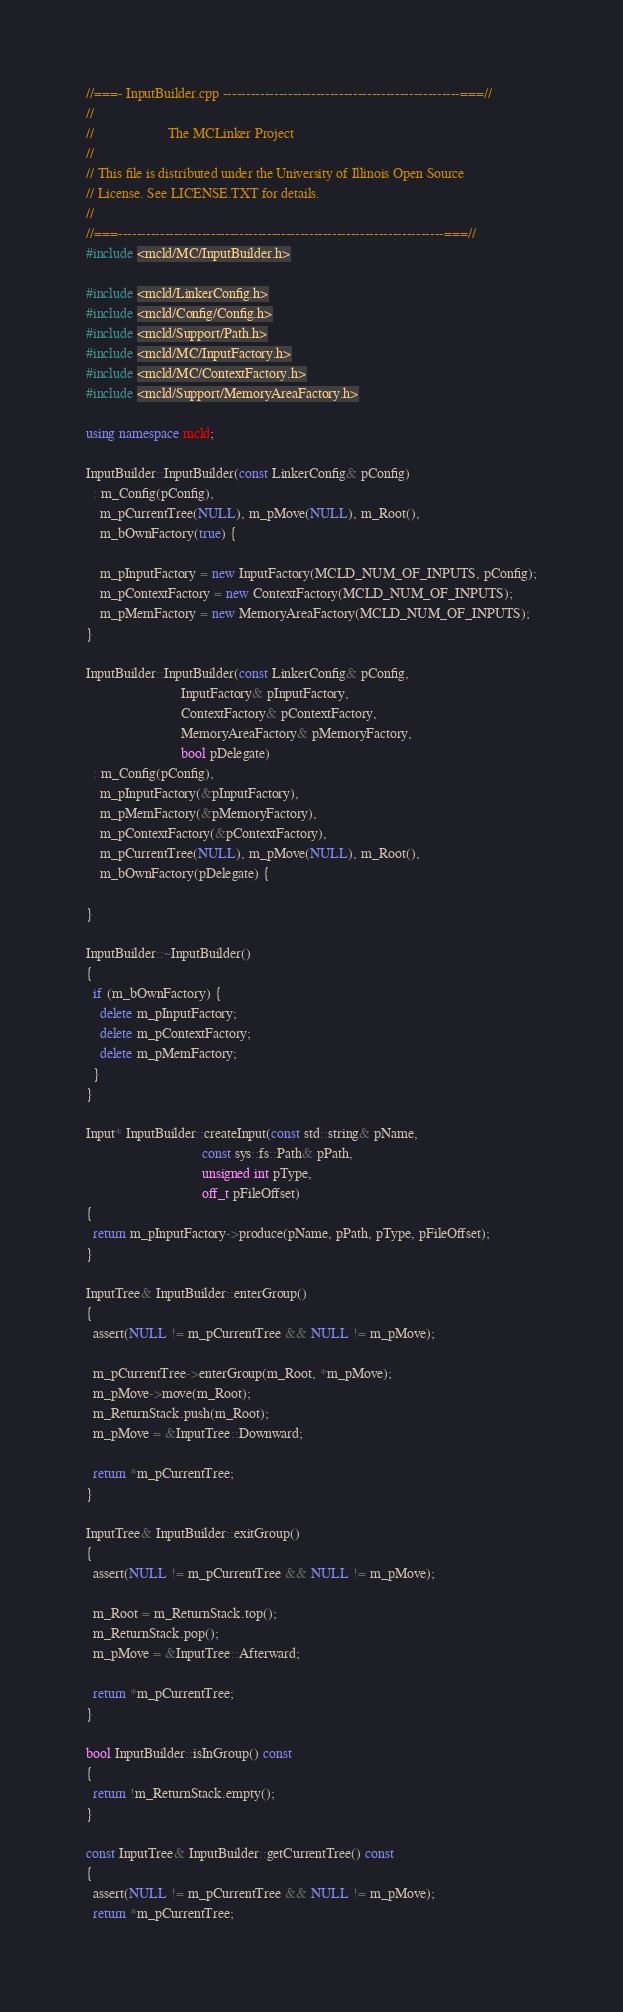<code> <loc_0><loc_0><loc_500><loc_500><_C++_>//===- InputBuilder.cpp ---------------------------------------------------===//
//
//                     The MCLinker Project
//
// This file is distributed under the University of Illinois Open Source
// License. See LICENSE.TXT for details.
//
//===----------------------------------------------------------------------===//
#include <mcld/MC/InputBuilder.h>

#include <mcld/LinkerConfig.h>
#include <mcld/Config/Config.h>
#include <mcld/Support/Path.h>
#include <mcld/MC/InputFactory.h>
#include <mcld/MC/ContextFactory.h>
#include <mcld/Support/MemoryAreaFactory.h>

using namespace mcld;

InputBuilder::InputBuilder(const LinkerConfig& pConfig)
  : m_Config(pConfig),
    m_pCurrentTree(NULL), m_pMove(NULL), m_Root(),
    m_bOwnFactory(true) {

    m_pInputFactory = new InputFactory(MCLD_NUM_OF_INPUTS, pConfig);
    m_pContextFactory = new ContextFactory(MCLD_NUM_OF_INPUTS);
    m_pMemFactory = new MemoryAreaFactory(MCLD_NUM_OF_INPUTS);
}

InputBuilder::InputBuilder(const LinkerConfig& pConfig,
                           InputFactory& pInputFactory,
                           ContextFactory& pContextFactory,
                           MemoryAreaFactory& pMemoryFactory,
                           bool pDelegate)
  : m_Config(pConfig),
    m_pInputFactory(&pInputFactory),
    m_pMemFactory(&pMemoryFactory),
    m_pContextFactory(&pContextFactory),
    m_pCurrentTree(NULL), m_pMove(NULL), m_Root(),
    m_bOwnFactory(pDelegate) {

}

InputBuilder::~InputBuilder()
{
  if (m_bOwnFactory) {
    delete m_pInputFactory;
    delete m_pContextFactory;
    delete m_pMemFactory;
  }
}

Input* InputBuilder::createInput(const std::string& pName,
                                 const sys::fs::Path& pPath,
                                 unsigned int pType,
                                 off_t pFileOffset)
{
  return m_pInputFactory->produce(pName, pPath, pType, pFileOffset);
}

InputTree& InputBuilder::enterGroup()
{
  assert(NULL != m_pCurrentTree && NULL != m_pMove);

  m_pCurrentTree->enterGroup(m_Root, *m_pMove);
  m_pMove->move(m_Root);
  m_ReturnStack.push(m_Root);
  m_pMove = &InputTree::Downward;

  return *m_pCurrentTree;
}

InputTree& InputBuilder::exitGroup()
{
  assert(NULL != m_pCurrentTree && NULL != m_pMove);

  m_Root = m_ReturnStack.top();
  m_ReturnStack.pop();
  m_pMove = &InputTree::Afterward;

  return *m_pCurrentTree;
}

bool InputBuilder::isInGroup() const
{
  return !m_ReturnStack.empty();
}

const InputTree& InputBuilder::getCurrentTree() const
{
  assert(NULL != m_pCurrentTree && NULL != m_pMove);
  return *m_pCurrentTree;</code> 